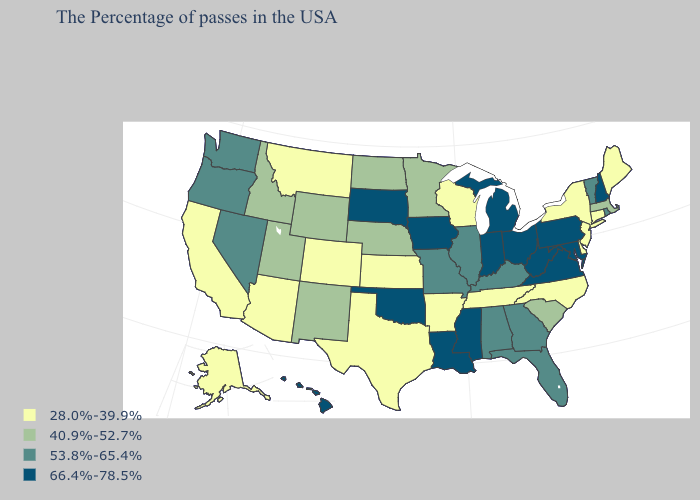What is the lowest value in the USA?
Quick response, please. 28.0%-39.9%. Among the states that border New York , does Pennsylvania have the lowest value?
Write a very short answer. No. Does Arizona have the same value as Alaska?
Give a very brief answer. Yes. Among the states that border Indiana , does Ohio have the highest value?
Keep it brief. Yes. Does the first symbol in the legend represent the smallest category?
Give a very brief answer. Yes. Name the states that have a value in the range 40.9%-52.7%?
Short answer required. Massachusetts, South Carolina, Minnesota, Nebraska, North Dakota, Wyoming, New Mexico, Utah, Idaho. Does the map have missing data?
Give a very brief answer. No. Does Arkansas have the lowest value in the South?
Write a very short answer. Yes. Among the states that border Missouri , does Illinois have the lowest value?
Concise answer only. No. What is the highest value in the USA?
Be succinct. 66.4%-78.5%. What is the highest value in the USA?
Give a very brief answer. 66.4%-78.5%. What is the lowest value in the South?
Keep it brief. 28.0%-39.9%. What is the lowest value in states that border Kentucky?
Short answer required. 28.0%-39.9%. Name the states that have a value in the range 53.8%-65.4%?
Be succinct. Rhode Island, Vermont, Florida, Georgia, Kentucky, Alabama, Illinois, Missouri, Nevada, Washington, Oregon. 